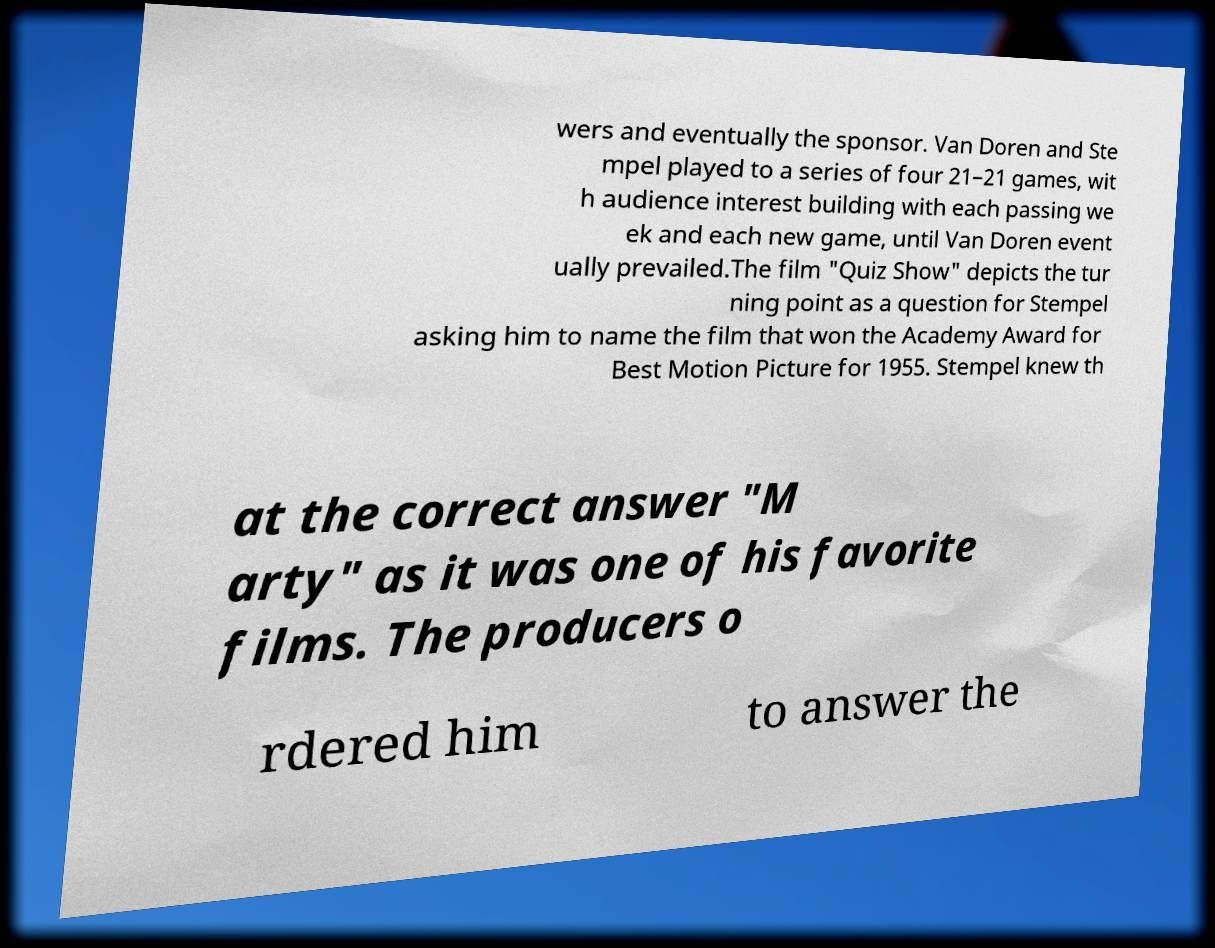Could you assist in decoding the text presented in this image and type it out clearly? wers and eventually the sponsor. Van Doren and Ste mpel played to a series of four 21–21 games, wit h audience interest building with each passing we ek and each new game, until Van Doren event ually prevailed.The film "Quiz Show" depicts the tur ning point as a question for Stempel asking him to name the film that won the Academy Award for Best Motion Picture for 1955. Stempel knew th at the correct answer "M arty" as it was one of his favorite films. The producers o rdered him to answer the 